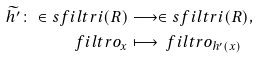Convert formula to latex. <formula><loc_0><loc_0><loc_500><loc_500>\widetilde { h ^ { \prime } } \colon \in s f i l t r i ( R ) & \longrightarrow \in s f i l t r i ( R ) , \\ \ f i l t r o _ { x } & \longmapsto \ f i l t r o _ { h ^ { \prime } ( x ) }</formula> 